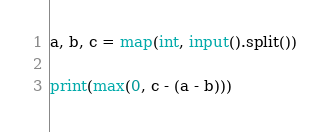<code> <loc_0><loc_0><loc_500><loc_500><_Python_>a, b, c = map(int, input().split())

print(max(0, c - (a - b)))

</code> 